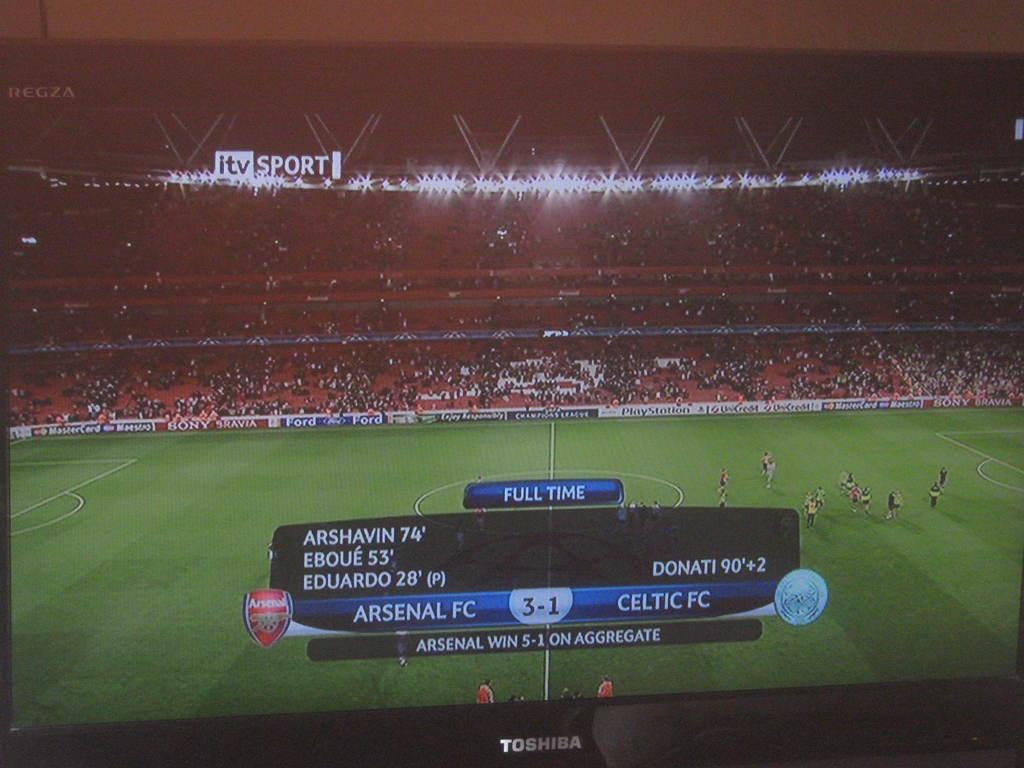What can be seen in the image? There are players in the image, and they are on a ground. What is written at the bottom of the image? There is text at the bottom of the image. What can be seen in the background of the image? There are chairs, a crowd, lights, and the sky visible in the background of the image. How many chickens are present in the image? There are no chickens present in the image. What type of tree can be seen in the background of the image? There is no tree visible in the image. 